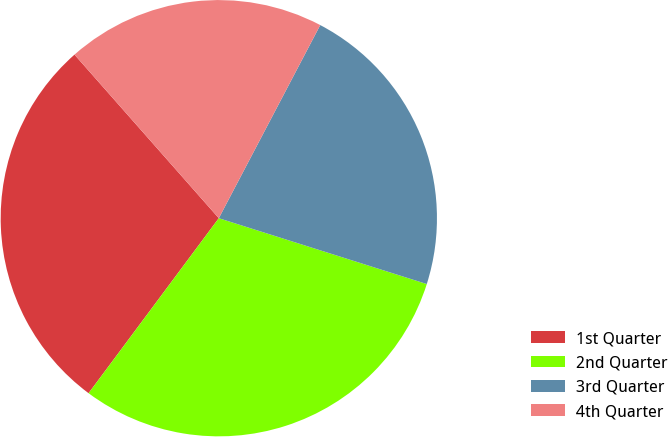Convert chart to OTSL. <chart><loc_0><loc_0><loc_500><loc_500><pie_chart><fcel>1st Quarter<fcel>2nd Quarter<fcel>3rd Quarter<fcel>4th Quarter<nl><fcel>28.31%<fcel>30.3%<fcel>22.18%<fcel>19.2%<nl></chart> 